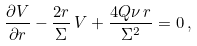<formula> <loc_0><loc_0><loc_500><loc_500>\frac { \partial V } { \partial r } - \frac { 2 r } { \Sigma } \, V + \frac { 4 Q \nu \, r } { \Sigma ^ { 2 } } = 0 \, ,</formula> 